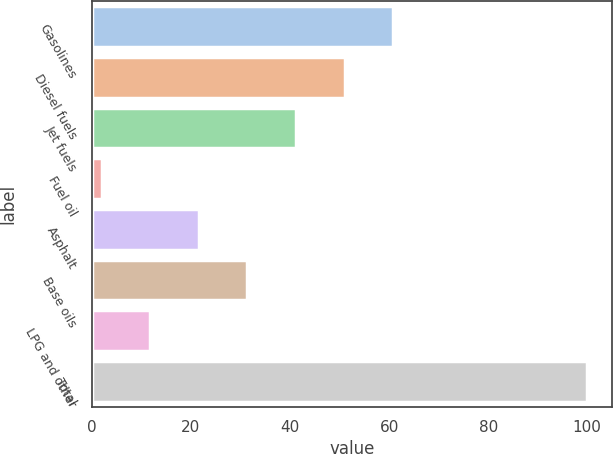Convert chart to OTSL. <chart><loc_0><loc_0><loc_500><loc_500><bar_chart><fcel>Gasolines<fcel>Diesel fuels<fcel>Jet fuels<fcel>Fuel oil<fcel>Asphalt<fcel>Base oils<fcel>LPG and other<fcel>Total<nl><fcel>60.8<fcel>51<fcel>41.2<fcel>2<fcel>21.6<fcel>31.4<fcel>11.8<fcel>100<nl></chart> 